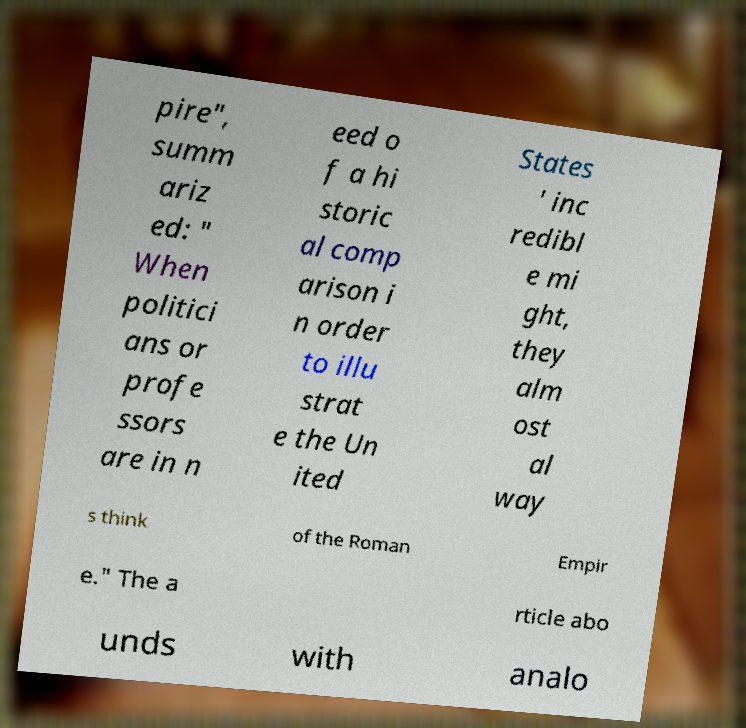Could you extract and type out the text from this image? pire", summ ariz ed: " When politici ans or profe ssors are in n eed o f a hi storic al comp arison i n order to illu strat e the Un ited States ' inc redibl e mi ght, they alm ost al way s think of the Roman Empir e." The a rticle abo unds with analo 